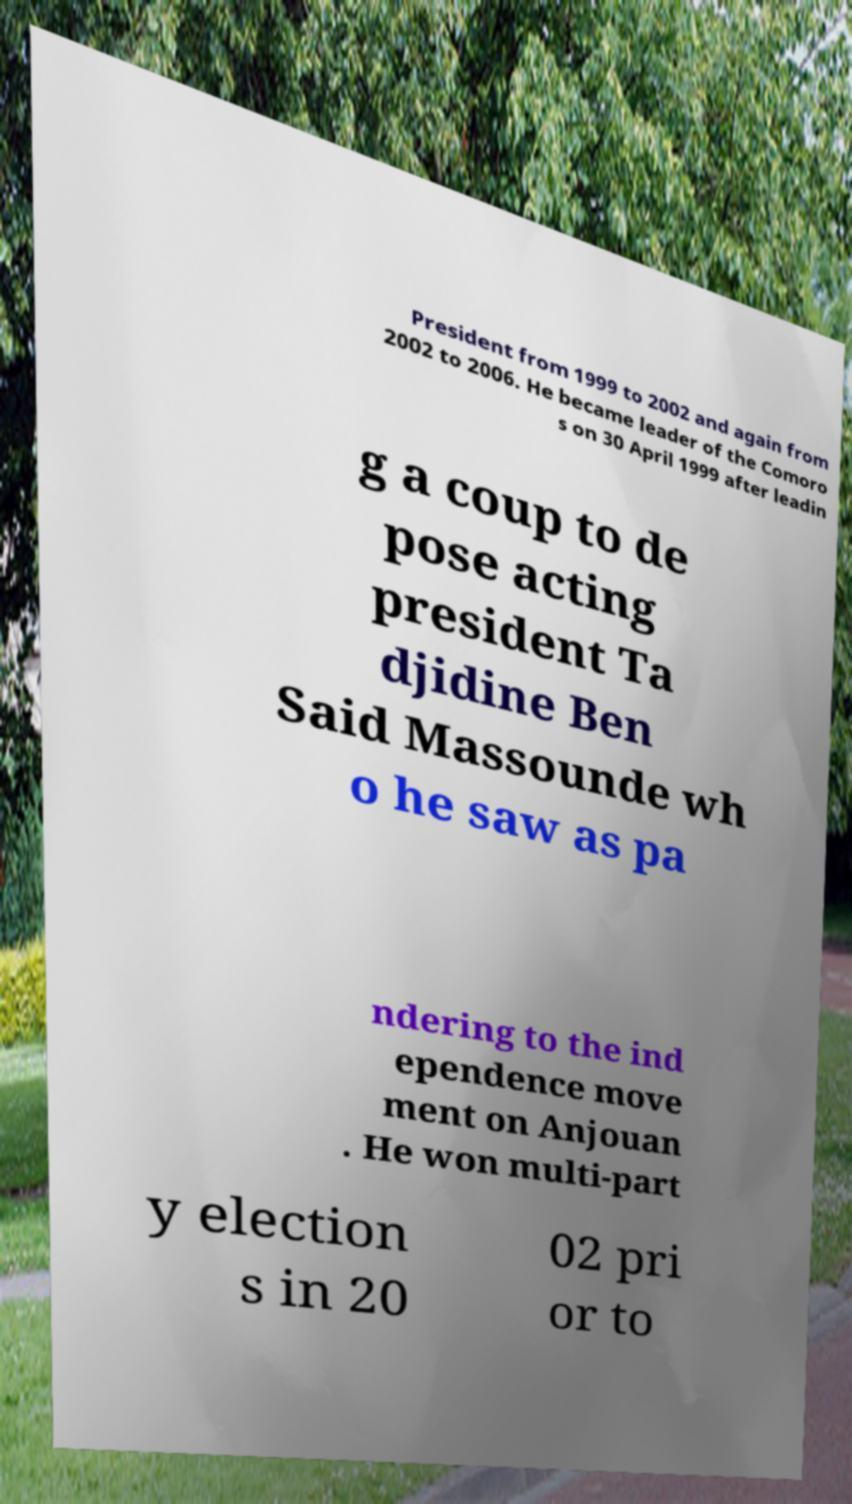Can you accurately transcribe the text from the provided image for me? President from 1999 to 2002 and again from 2002 to 2006. He became leader of the Comoro s on 30 April 1999 after leadin g a coup to de pose acting president Ta djidine Ben Said Massounde wh o he saw as pa ndering to the ind ependence move ment on Anjouan . He won multi-part y election s in 20 02 pri or to 